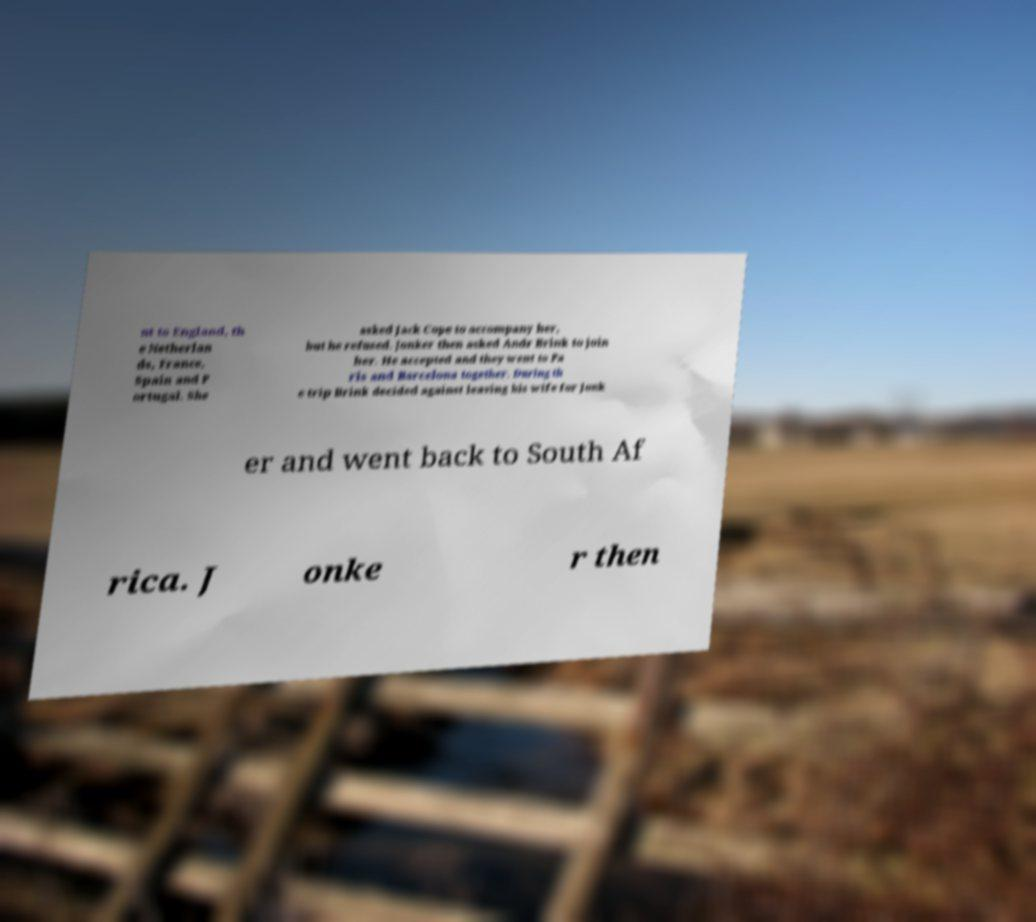Could you extract and type out the text from this image? nt to England, th e Netherlan ds, France, Spain and P ortugal. She asked Jack Cope to accompany her, but he refused. Jonker then asked Andr Brink to join her. He accepted and they went to Pa ris and Barcelona together. During th e trip Brink decided against leaving his wife for Jonk er and went back to South Af rica. J onke r then 